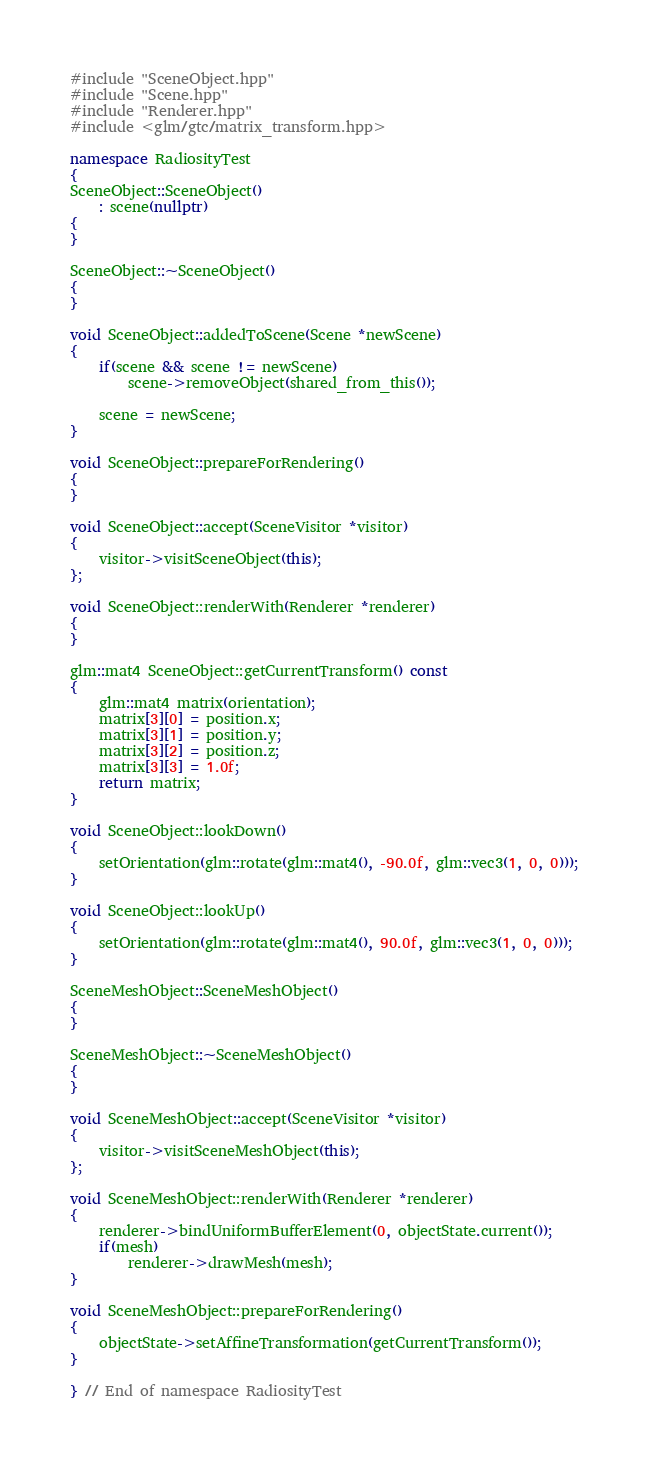Convert code to text. <code><loc_0><loc_0><loc_500><loc_500><_C++_>#include "SceneObject.hpp"
#include "Scene.hpp"
#include "Renderer.hpp"
#include <glm/gtc/matrix_transform.hpp>

namespace RadiosityTest
{
SceneObject::SceneObject()
    : scene(nullptr)
{
}

SceneObject::~SceneObject()
{
}

void SceneObject::addedToScene(Scene *newScene)
{
    if(scene && scene != newScene)
        scene->removeObject(shared_from_this());

    scene = newScene;
}

void SceneObject::prepareForRendering()
{
}

void SceneObject::accept(SceneVisitor *visitor)
{
    visitor->visitSceneObject(this);
};

void SceneObject::renderWith(Renderer *renderer)
{
}

glm::mat4 SceneObject::getCurrentTransform() const
{
    glm::mat4 matrix(orientation);
    matrix[3][0] = position.x;
    matrix[3][1] = position.y;
    matrix[3][2] = position.z;
    matrix[3][3] = 1.0f;
    return matrix;
}

void SceneObject::lookDown()
{
    setOrientation(glm::rotate(glm::mat4(), -90.0f, glm::vec3(1, 0, 0)));
}

void SceneObject::lookUp()
{
    setOrientation(glm::rotate(glm::mat4(), 90.0f, glm::vec3(1, 0, 0)));
}

SceneMeshObject::SceneMeshObject()
{
}

SceneMeshObject::~SceneMeshObject()
{
}

void SceneMeshObject::accept(SceneVisitor *visitor)
{
    visitor->visitSceneMeshObject(this);
};

void SceneMeshObject::renderWith(Renderer *renderer)
{
    renderer->bindUniformBufferElement(0, objectState.current());
    if(mesh)
        renderer->drawMesh(mesh);
}

void SceneMeshObject::prepareForRendering()
{
    objectState->setAffineTransformation(getCurrentTransform());
}

} // End of namespace RadiosityTest
</code> 